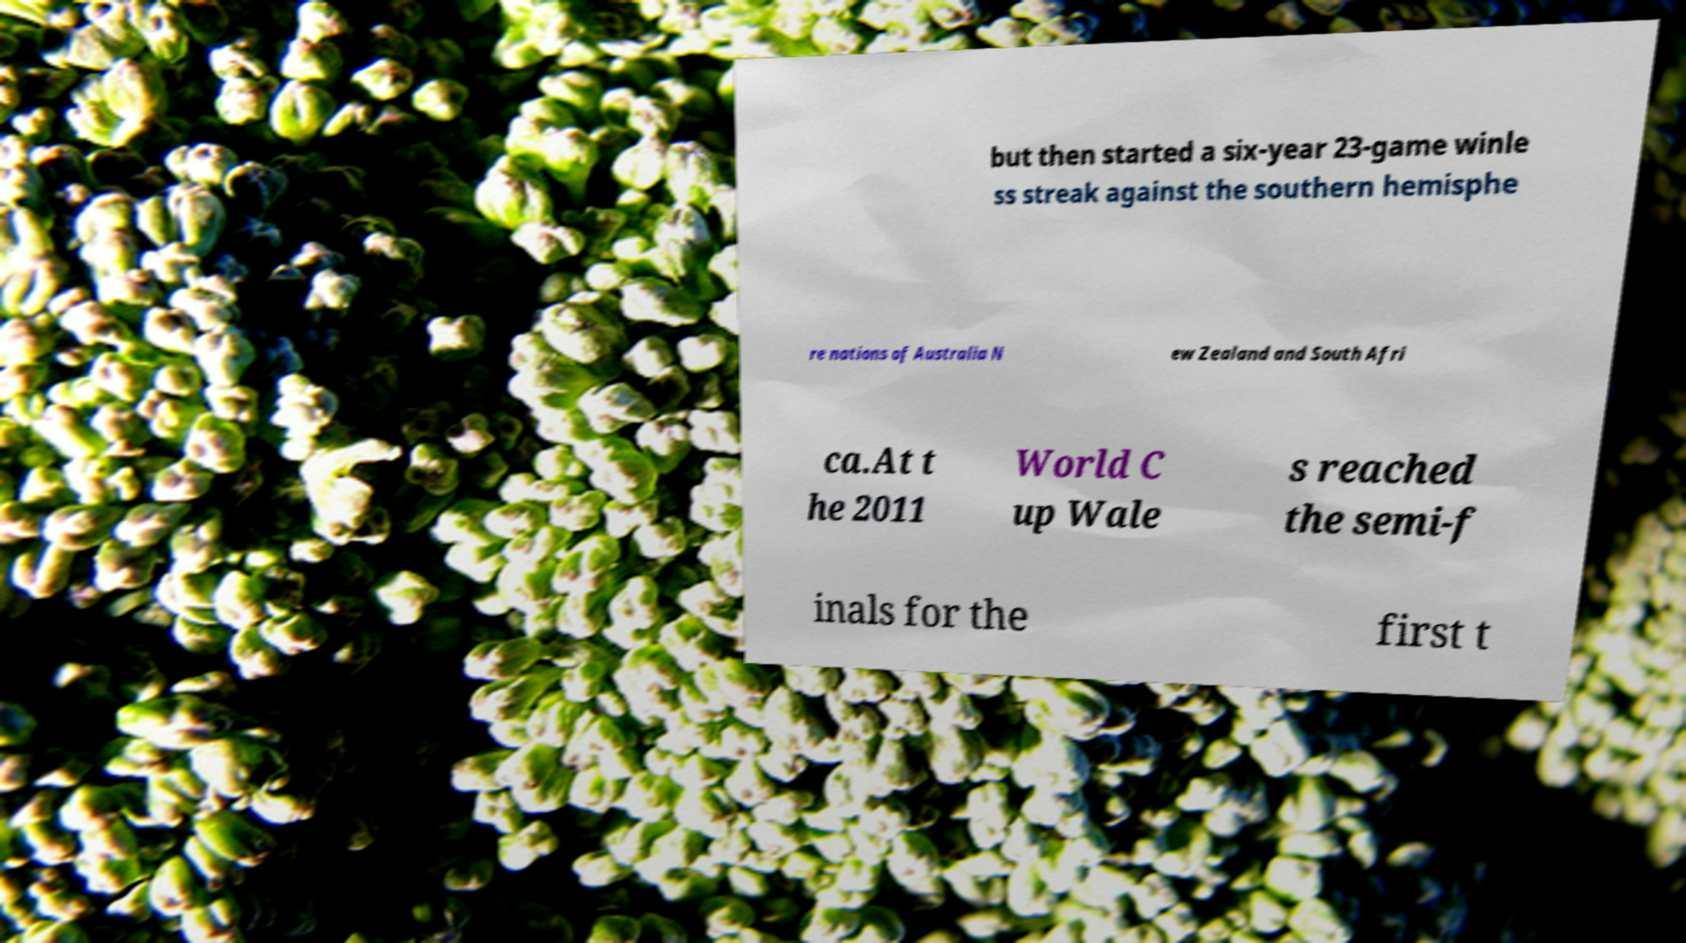What messages or text are displayed in this image? I need them in a readable, typed format. but then started a six-year 23-game winle ss streak against the southern hemisphe re nations of Australia N ew Zealand and South Afri ca.At t he 2011 World C up Wale s reached the semi-f inals for the first t 